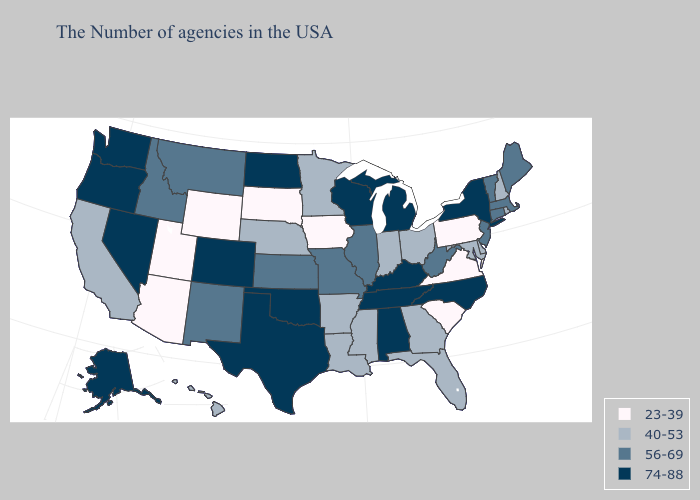Name the states that have a value in the range 40-53?
Keep it brief. Rhode Island, New Hampshire, Delaware, Maryland, Ohio, Florida, Georgia, Indiana, Mississippi, Louisiana, Arkansas, Minnesota, Nebraska, California, Hawaii. Name the states that have a value in the range 74-88?
Be succinct. New York, North Carolina, Michigan, Kentucky, Alabama, Tennessee, Wisconsin, Oklahoma, Texas, North Dakota, Colorado, Nevada, Washington, Oregon, Alaska. Among the states that border Oregon , does Idaho have the lowest value?
Be succinct. No. What is the lowest value in states that border Oklahoma?
Keep it brief. 40-53. Name the states that have a value in the range 23-39?
Be succinct. Pennsylvania, Virginia, South Carolina, Iowa, South Dakota, Wyoming, Utah, Arizona. What is the highest value in the USA?
Write a very short answer. 74-88. How many symbols are there in the legend?
Short answer required. 4. Which states have the lowest value in the Northeast?
Be succinct. Pennsylvania. Does Maryland have a lower value than Washington?
Answer briefly. Yes. What is the value of New Mexico?
Concise answer only. 56-69. Name the states that have a value in the range 56-69?
Give a very brief answer. Maine, Massachusetts, Vermont, Connecticut, New Jersey, West Virginia, Illinois, Missouri, Kansas, New Mexico, Montana, Idaho. Name the states that have a value in the range 74-88?
Quick response, please. New York, North Carolina, Michigan, Kentucky, Alabama, Tennessee, Wisconsin, Oklahoma, Texas, North Dakota, Colorado, Nevada, Washington, Oregon, Alaska. How many symbols are there in the legend?
Give a very brief answer. 4. What is the lowest value in the USA?
Short answer required. 23-39. Which states have the lowest value in the Northeast?
Answer briefly. Pennsylvania. 